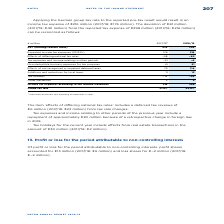According to Metro Ag's financial document, What does the item ‘effects of differing national tax rates’ include? a deferred tax revenue of €6 million (2017/18: €23 million) from tax rate changes.. The document states: "‘effects of differing national tax rates’ includes a deferred tax revenue of €6 million (2017/18: €23 million) from tax rate changes. Tax expenses and..." Also, What would the income tax expense in FY2019 be if the German group tax rate was applied to the reported pre-tax result? According to the financial document, €216 million. The relevant text states: "income tax expense of €216 million (2017/18: €176 million). The deviation of €81 million income tax expense of €216 million (2017/18: €176 million). The deviation of €81 million..." Also, In which years were the Group tax rate provided in the table? The document shows two values: 2017/2018 and 2018/2019. Additionally, In which year was the Group tax rate larger? Based on the financial document, the answer is 2018/2019. Also, can you calculate: What was the change in EBT in 2018/2019 from 2017/2018? Based on the calculation: 709-576, the result is 133 (in millions). This is based on the information: "EBT (earnings before taxes) 576 709 EBT (earnings before taxes) 576 709..." The key data points involved are: 576, 709. Also, can you calculate: What was the percentage change in EBT in 2018/2019 from 2017/2018? To answer this question, I need to perform calculations using the financial data. The calculation is: (709-576)/576, which equals 23.09 (percentage). This is based on the information: "EBT (earnings before taxes) 576 709 EBT (earnings before taxes) 576 709..." The key data points involved are: 576, 709. 